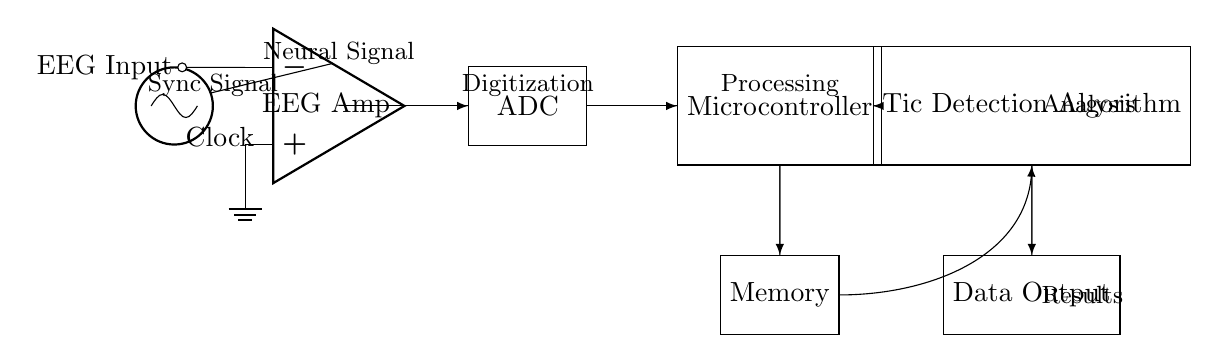What component generates the synchronization signal? The synchronization signal is generated by the Clock component, as depicted at the leftmost part of the diagram. It provides a timing reference for the data acquisition system.
Answer: Clock What is the primary function of the EEG Amplifier? The EEG Amplifier's primary function is to amplify the neural signals received from the EEG input, ensuring that they are strong enough for further processing in the ADC.
Answer: Amplification Which component is responsible for digitizing the analog signal? The component that digitizes the analog neural signals is the ADC, which converts the amplified analog signals from the EEG Amplifier into digital data for processing.
Answer: ADC How does the Microcontroller interact with the Memory? The Microcontroller interacts with the Memory by sending and potentially receiving data. It stores processed information from the neural activity in the Memory for future retrieval and analysis.
Answer: Data exchange What is the output of the Tic Detection Algorithm? The output of the Tic Detection Algorithm is the results, which is informational data regarding the tic episodes analyzed from the neural signals.
Answer: Data Output How many phases does the processing of neural signals undergo in this circuit? The processing of neural signals undergoes three phases: amplification (by the EEG Amplifier), digitization (by the ADC), and analysis (by the Tic Detection Algorithm).
Answer: Three phases What does the flow of arrows indicate in the circuit diagram? The flow of arrows indicates the direction of data flow between the different components in the circuit, showing how information is processed sequentially from one component to another.
Answer: Data flow 